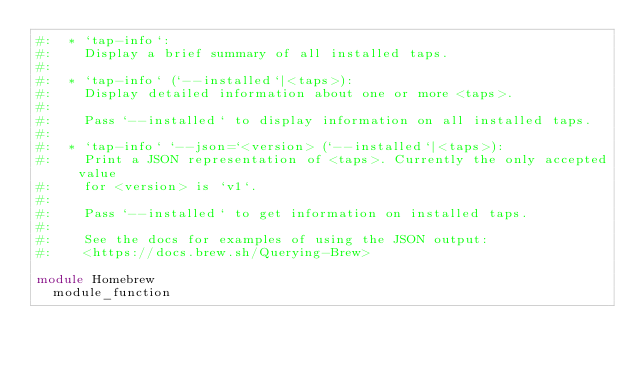<code> <loc_0><loc_0><loc_500><loc_500><_Ruby_>#:  * `tap-info`:
#:    Display a brief summary of all installed taps.
#:
#:  * `tap-info` (`--installed`|<taps>):
#:    Display detailed information about one or more <taps>.
#:
#:    Pass `--installed` to display information on all installed taps.
#:
#:  * `tap-info` `--json=`<version> (`--installed`|<taps>):
#:    Print a JSON representation of <taps>. Currently the only accepted value
#:    for <version> is `v1`.
#:
#:    Pass `--installed` to get information on installed taps.
#:
#:    See the docs for examples of using the JSON output:
#:    <https://docs.brew.sh/Querying-Brew>

module Homebrew
  module_function
</code> 